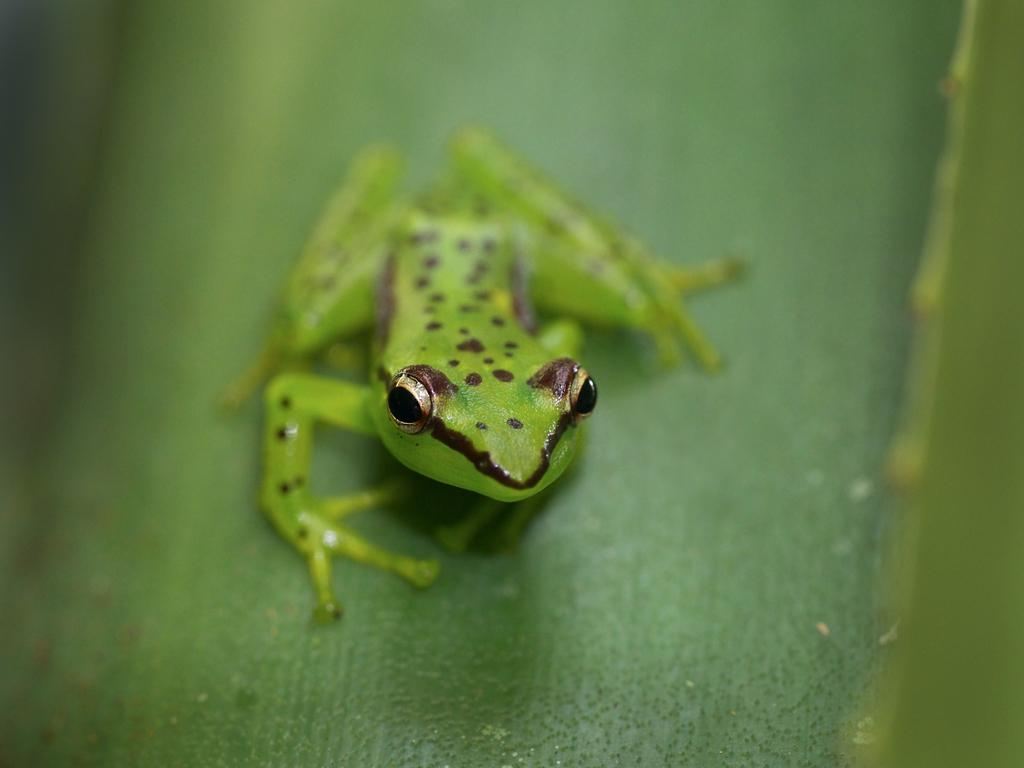What type of animal is in the image? There is a frog in the image. What colors can be seen on the frog? The frog is green and brown in color. Where is the frog located in the image? The frog is on a leaf. What color is the leaf that the frog is on? The leaf is green in color. What time of day is depicted in the image? The image does not provide any information about the time of day. --- Facts: 1. There is a car in the image. 2. The car is red. 3. The car has four wheels. 4. There is a road in the image. 5. The road is paved. Absurd Topics: ocean, bird, mountain Conversation: What type of vehicle is in the image? There is a car in the image. What color is the car? The car is red. How many wheels does the car have? The car has four wheels. What type of surface is the car on? There is a road in the image, and it is paved. Reasoning: Let's think step by step in order to produce the conversation. We start by identifying the main subject in the image, which is the car. Then, we describe the car's appearance, including its color. Next, we mention the car's features, such as the number of wheels. Finally, we describe the car's location, which is on a paved road. Each question is designed to elicit a specific detail about the image that is known from the provided facts. Absurd Question/Answer: Can you see any mountains in the image? There are no mountains visible in the image; it features a car on a road. 